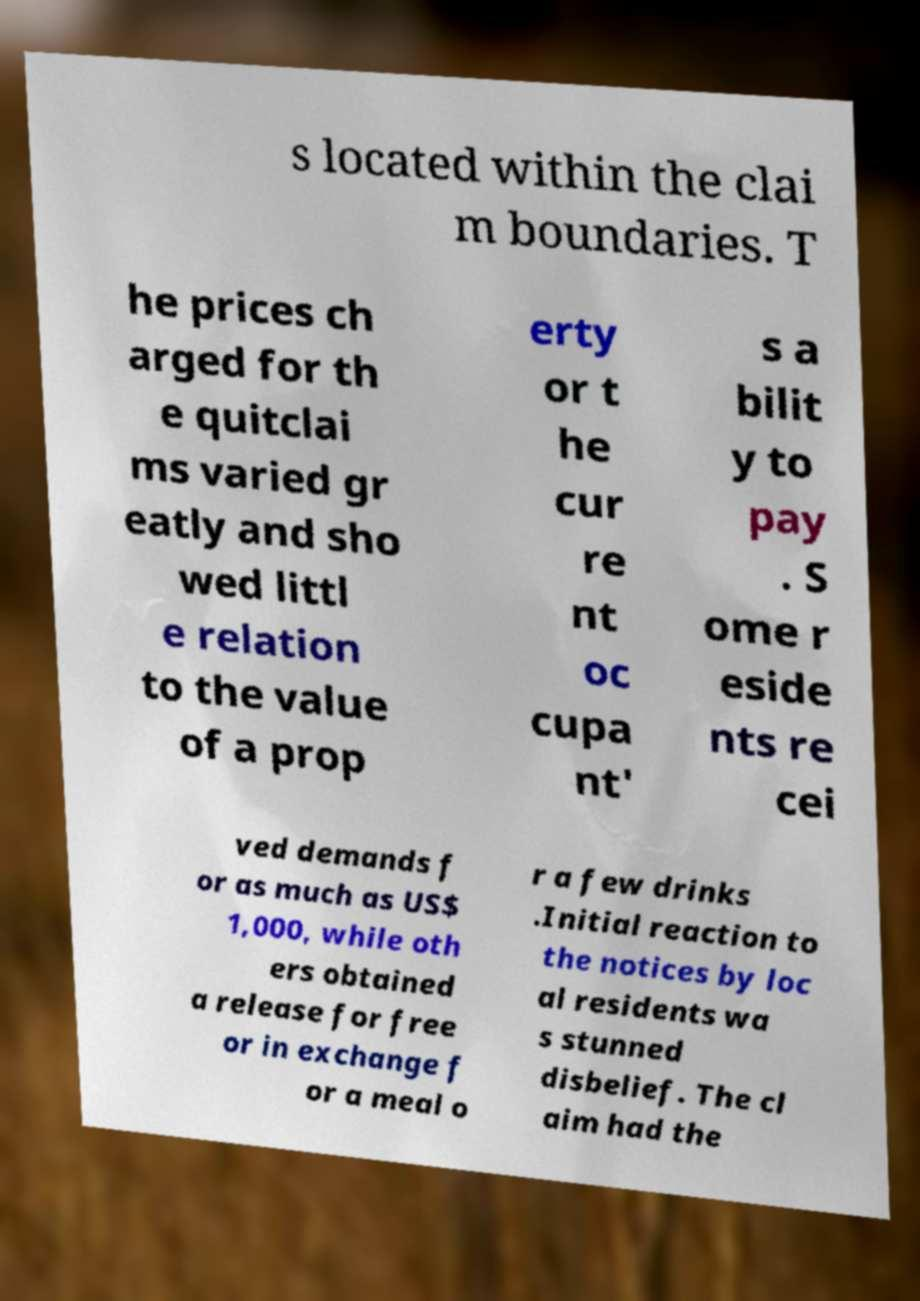Could you extract and type out the text from this image? s located within the clai m boundaries. T he prices ch arged for th e quitclai ms varied gr eatly and sho wed littl e relation to the value of a prop erty or t he cur re nt oc cupa nt' s a bilit y to pay . S ome r eside nts re cei ved demands f or as much as US$ 1,000, while oth ers obtained a release for free or in exchange f or a meal o r a few drinks .Initial reaction to the notices by loc al residents wa s stunned disbelief. The cl aim had the 